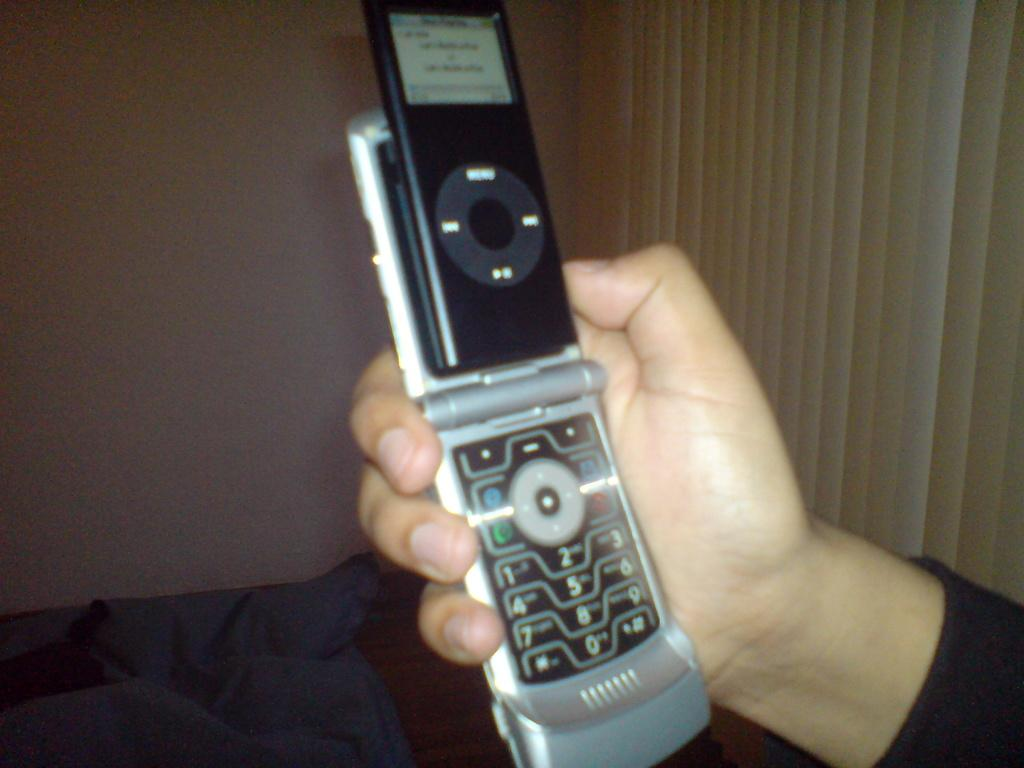What part of a person's body is visible in the image? There is a person's hand in the image. What is the person holding in their hand? The person is holding a mobile in their hand. What can be seen in the background of the image? There is a wall in the background of the image. What type of authority is depicted in the image? There is no authority figure present in the image; it only shows a person's hand holding a mobile. 